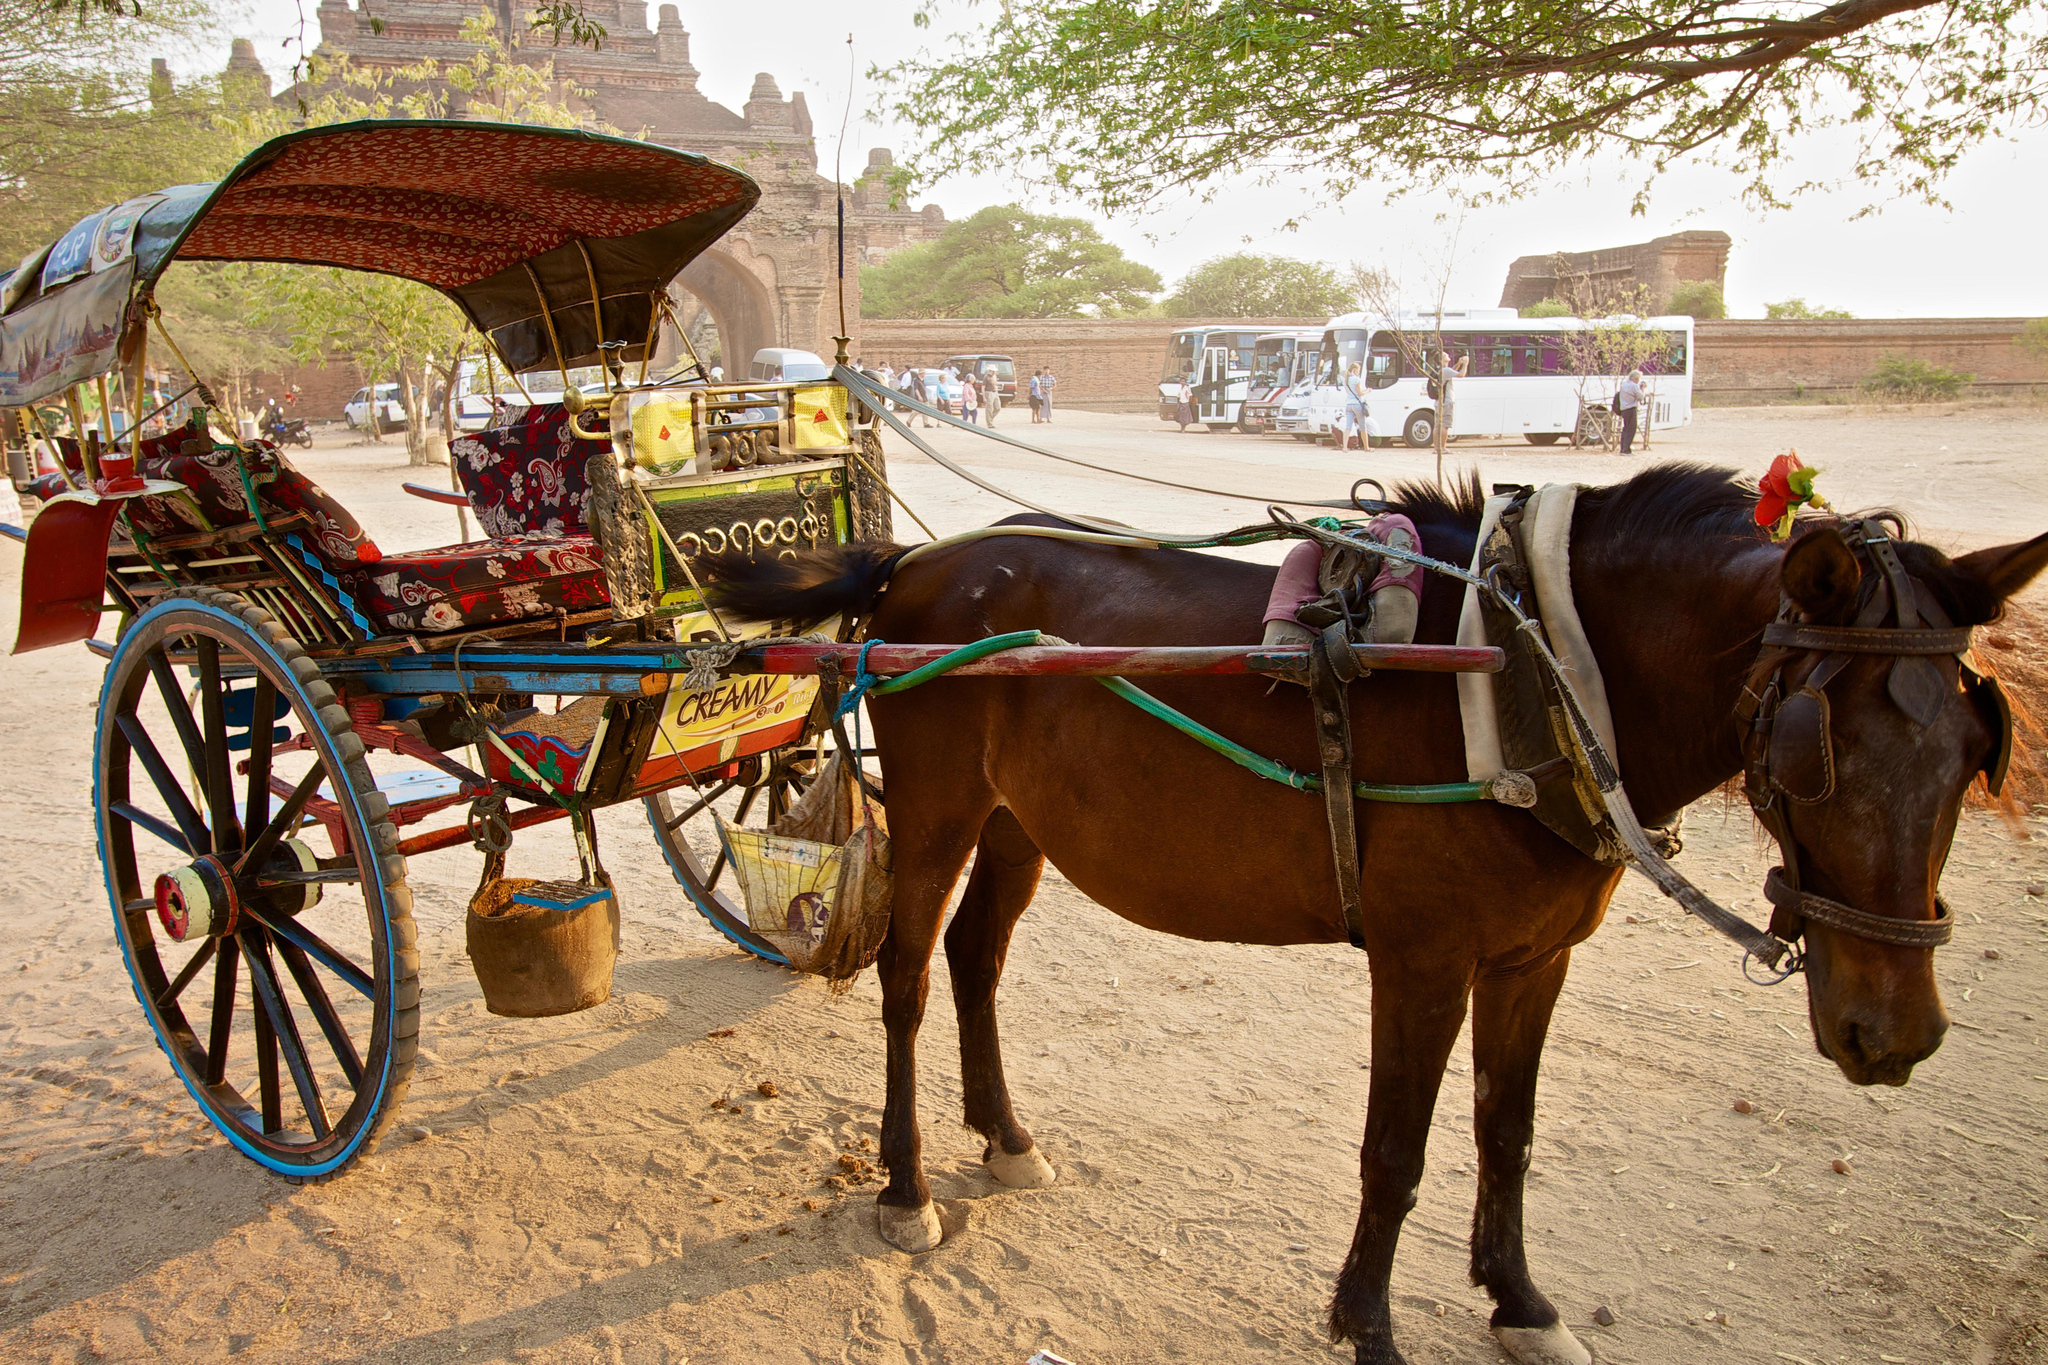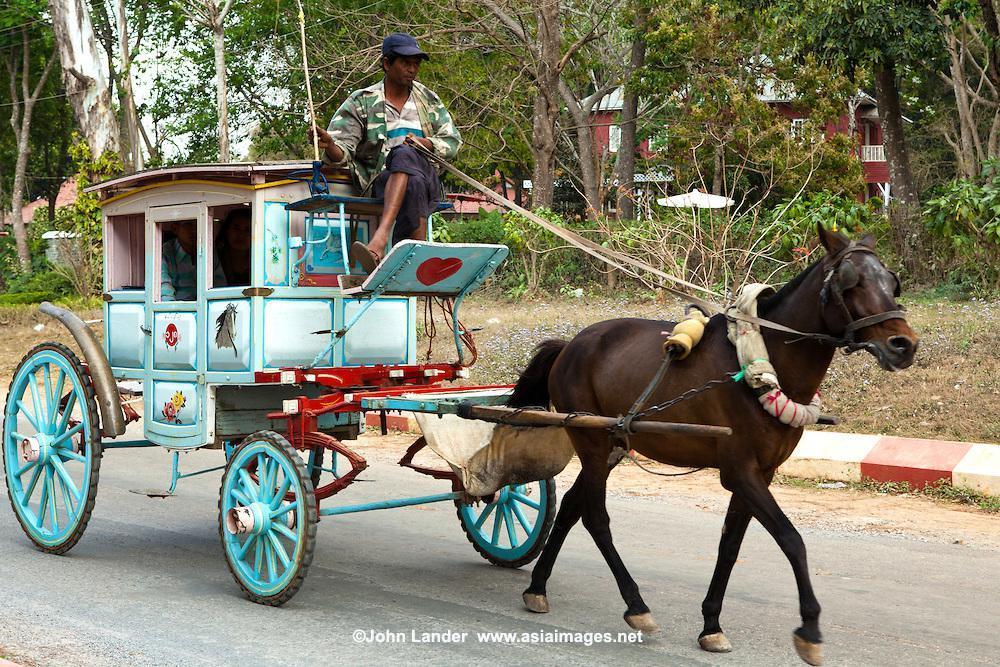The first image is the image on the left, the second image is the image on the right. For the images displayed, is the sentence "There is at least one person in the image on the left." factually correct? Answer yes or no. No. The first image is the image on the left, the second image is the image on the right. Given the left and right images, does the statement "The left image shows a two wheel cart without a person riding in it." hold true? Answer yes or no. Yes. 